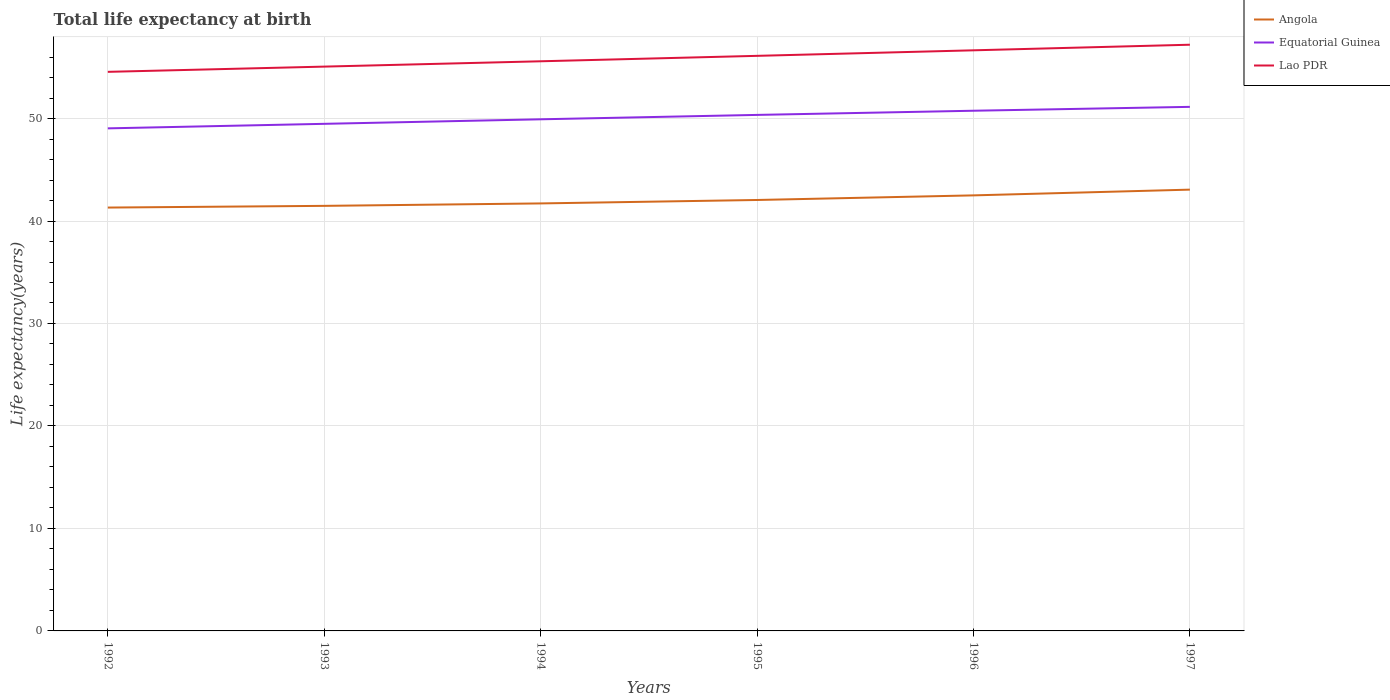How many different coloured lines are there?
Provide a succinct answer. 3. Does the line corresponding to Lao PDR intersect with the line corresponding to Angola?
Your response must be concise. No. Is the number of lines equal to the number of legend labels?
Make the answer very short. Yes. Across all years, what is the maximum life expectancy at birth in in Angola?
Your response must be concise. 41.31. What is the total life expectancy at birth in in Lao PDR in the graph?
Give a very brief answer. -0.55. What is the difference between the highest and the second highest life expectancy at birth in in Angola?
Keep it short and to the point. 1.75. How many lines are there?
Your answer should be compact. 3. What is the title of the graph?
Give a very brief answer. Total life expectancy at birth. Does "Tanzania" appear as one of the legend labels in the graph?
Offer a terse response. No. What is the label or title of the X-axis?
Make the answer very short. Years. What is the label or title of the Y-axis?
Provide a succinct answer. Life expectancy(years). What is the Life expectancy(years) in Angola in 1992?
Offer a very short reply. 41.31. What is the Life expectancy(years) of Equatorial Guinea in 1992?
Keep it short and to the point. 49.04. What is the Life expectancy(years) in Lao PDR in 1992?
Your response must be concise. 54.56. What is the Life expectancy(years) in Angola in 1993?
Your answer should be compact. 41.48. What is the Life expectancy(years) of Equatorial Guinea in 1993?
Your answer should be very brief. 49.48. What is the Life expectancy(years) in Lao PDR in 1993?
Offer a very short reply. 55.07. What is the Life expectancy(years) of Angola in 1994?
Your answer should be compact. 41.72. What is the Life expectancy(years) of Equatorial Guinea in 1994?
Keep it short and to the point. 49.93. What is the Life expectancy(years) in Lao PDR in 1994?
Make the answer very short. 55.59. What is the Life expectancy(years) of Angola in 1995?
Make the answer very short. 42.05. What is the Life expectancy(years) in Equatorial Guinea in 1995?
Keep it short and to the point. 50.35. What is the Life expectancy(years) in Lao PDR in 1995?
Give a very brief answer. 56.12. What is the Life expectancy(years) of Angola in 1996?
Make the answer very short. 42.5. What is the Life expectancy(years) of Equatorial Guinea in 1996?
Offer a very short reply. 50.76. What is the Life expectancy(years) in Lao PDR in 1996?
Your answer should be very brief. 56.66. What is the Life expectancy(years) of Angola in 1997?
Give a very brief answer. 43.06. What is the Life expectancy(years) of Equatorial Guinea in 1997?
Ensure brevity in your answer.  51.14. What is the Life expectancy(years) of Lao PDR in 1997?
Make the answer very short. 57.2. Across all years, what is the maximum Life expectancy(years) in Angola?
Offer a terse response. 43.06. Across all years, what is the maximum Life expectancy(years) of Equatorial Guinea?
Ensure brevity in your answer.  51.14. Across all years, what is the maximum Life expectancy(years) in Lao PDR?
Your answer should be compact. 57.2. Across all years, what is the minimum Life expectancy(years) in Angola?
Offer a very short reply. 41.31. Across all years, what is the minimum Life expectancy(years) in Equatorial Guinea?
Provide a short and direct response. 49.04. Across all years, what is the minimum Life expectancy(years) of Lao PDR?
Ensure brevity in your answer.  54.56. What is the total Life expectancy(years) in Angola in the graph?
Your answer should be very brief. 252.12. What is the total Life expectancy(years) of Equatorial Guinea in the graph?
Make the answer very short. 300.71. What is the total Life expectancy(years) in Lao PDR in the graph?
Make the answer very short. 335.19. What is the difference between the Life expectancy(years) in Angola in 1992 and that in 1993?
Keep it short and to the point. -0.17. What is the difference between the Life expectancy(years) of Equatorial Guinea in 1992 and that in 1993?
Your answer should be very brief. -0.44. What is the difference between the Life expectancy(years) of Lao PDR in 1992 and that in 1993?
Your answer should be compact. -0.51. What is the difference between the Life expectancy(years) in Angola in 1992 and that in 1994?
Keep it short and to the point. -0.4. What is the difference between the Life expectancy(years) in Equatorial Guinea in 1992 and that in 1994?
Your answer should be compact. -0.88. What is the difference between the Life expectancy(years) of Lao PDR in 1992 and that in 1994?
Your response must be concise. -1.03. What is the difference between the Life expectancy(years) in Angola in 1992 and that in 1995?
Keep it short and to the point. -0.74. What is the difference between the Life expectancy(years) of Equatorial Guinea in 1992 and that in 1995?
Give a very brief answer. -1.31. What is the difference between the Life expectancy(years) in Lao PDR in 1992 and that in 1995?
Give a very brief answer. -1.56. What is the difference between the Life expectancy(years) of Angola in 1992 and that in 1996?
Keep it short and to the point. -1.19. What is the difference between the Life expectancy(years) of Equatorial Guinea in 1992 and that in 1996?
Offer a very short reply. -1.72. What is the difference between the Life expectancy(years) in Lao PDR in 1992 and that in 1996?
Your answer should be very brief. -2.1. What is the difference between the Life expectancy(years) of Angola in 1992 and that in 1997?
Your answer should be compact. -1.75. What is the difference between the Life expectancy(years) in Equatorial Guinea in 1992 and that in 1997?
Your answer should be very brief. -2.1. What is the difference between the Life expectancy(years) in Lao PDR in 1992 and that in 1997?
Make the answer very short. -2.65. What is the difference between the Life expectancy(years) of Angola in 1993 and that in 1994?
Make the answer very short. -0.24. What is the difference between the Life expectancy(years) of Equatorial Guinea in 1993 and that in 1994?
Your response must be concise. -0.44. What is the difference between the Life expectancy(years) of Lao PDR in 1993 and that in 1994?
Keep it short and to the point. -0.52. What is the difference between the Life expectancy(years) in Angola in 1993 and that in 1995?
Make the answer very short. -0.57. What is the difference between the Life expectancy(years) in Equatorial Guinea in 1993 and that in 1995?
Provide a short and direct response. -0.87. What is the difference between the Life expectancy(years) in Lao PDR in 1993 and that in 1995?
Make the answer very short. -1.05. What is the difference between the Life expectancy(years) in Angola in 1993 and that in 1996?
Give a very brief answer. -1.02. What is the difference between the Life expectancy(years) of Equatorial Guinea in 1993 and that in 1996?
Provide a succinct answer. -1.28. What is the difference between the Life expectancy(years) of Lao PDR in 1993 and that in 1996?
Provide a succinct answer. -1.59. What is the difference between the Life expectancy(years) of Angola in 1993 and that in 1997?
Give a very brief answer. -1.58. What is the difference between the Life expectancy(years) of Equatorial Guinea in 1993 and that in 1997?
Offer a terse response. -1.66. What is the difference between the Life expectancy(years) of Lao PDR in 1993 and that in 1997?
Your answer should be compact. -2.14. What is the difference between the Life expectancy(years) of Angola in 1994 and that in 1995?
Your response must be concise. -0.34. What is the difference between the Life expectancy(years) of Equatorial Guinea in 1994 and that in 1995?
Make the answer very short. -0.43. What is the difference between the Life expectancy(years) in Lao PDR in 1994 and that in 1995?
Your answer should be very brief. -0.53. What is the difference between the Life expectancy(years) in Angola in 1994 and that in 1996?
Make the answer very short. -0.79. What is the difference between the Life expectancy(years) of Equatorial Guinea in 1994 and that in 1996?
Provide a succinct answer. -0.84. What is the difference between the Life expectancy(years) in Lao PDR in 1994 and that in 1996?
Your answer should be very brief. -1.07. What is the difference between the Life expectancy(years) of Angola in 1994 and that in 1997?
Ensure brevity in your answer.  -1.35. What is the difference between the Life expectancy(years) of Equatorial Guinea in 1994 and that in 1997?
Keep it short and to the point. -1.21. What is the difference between the Life expectancy(years) of Lao PDR in 1994 and that in 1997?
Make the answer very short. -1.62. What is the difference between the Life expectancy(years) in Angola in 1995 and that in 1996?
Offer a very short reply. -0.45. What is the difference between the Life expectancy(years) in Equatorial Guinea in 1995 and that in 1996?
Offer a very short reply. -0.41. What is the difference between the Life expectancy(years) of Lao PDR in 1995 and that in 1996?
Provide a succinct answer. -0.54. What is the difference between the Life expectancy(years) in Angola in 1995 and that in 1997?
Make the answer very short. -1.01. What is the difference between the Life expectancy(years) in Equatorial Guinea in 1995 and that in 1997?
Provide a short and direct response. -0.78. What is the difference between the Life expectancy(years) of Lao PDR in 1995 and that in 1997?
Provide a succinct answer. -1.09. What is the difference between the Life expectancy(years) of Angola in 1996 and that in 1997?
Keep it short and to the point. -0.56. What is the difference between the Life expectancy(years) of Equatorial Guinea in 1996 and that in 1997?
Your answer should be very brief. -0.38. What is the difference between the Life expectancy(years) of Lao PDR in 1996 and that in 1997?
Ensure brevity in your answer.  -0.55. What is the difference between the Life expectancy(years) in Angola in 1992 and the Life expectancy(years) in Equatorial Guinea in 1993?
Ensure brevity in your answer.  -8.17. What is the difference between the Life expectancy(years) in Angola in 1992 and the Life expectancy(years) in Lao PDR in 1993?
Make the answer very short. -13.75. What is the difference between the Life expectancy(years) in Equatorial Guinea in 1992 and the Life expectancy(years) in Lao PDR in 1993?
Make the answer very short. -6.03. What is the difference between the Life expectancy(years) of Angola in 1992 and the Life expectancy(years) of Equatorial Guinea in 1994?
Your response must be concise. -8.61. What is the difference between the Life expectancy(years) of Angola in 1992 and the Life expectancy(years) of Lao PDR in 1994?
Your response must be concise. -14.27. What is the difference between the Life expectancy(years) in Equatorial Guinea in 1992 and the Life expectancy(years) in Lao PDR in 1994?
Your answer should be very brief. -6.55. What is the difference between the Life expectancy(years) of Angola in 1992 and the Life expectancy(years) of Equatorial Guinea in 1995?
Offer a terse response. -9.04. What is the difference between the Life expectancy(years) in Angola in 1992 and the Life expectancy(years) in Lao PDR in 1995?
Offer a very short reply. -14.8. What is the difference between the Life expectancy(years) of Equatorial Guinea in 1992 and the Life expectancy(years) of Lao PDR in 1995?
Your answer should be compact. -7.08. What is the difference between the Life expectancy(years) of Angola in 1992 and the Life expectancy(years) of Equatorial Guinea in 1996?
Make the answer very short. -9.45. What is the difference between the Life expectancy(years) in Angola in 1992 and the Life expectancy(years) in Lao PDR in 1996?
Your answer should be very brief. -15.34. What is the difference between the Life expectancy(years) in Equatorial Guinea in 1992 and the Life expectancy(years) in Lao PDR in 1996?
Keep it short and to the point. -7.62. What is the difference between the Life expectancy(years) in Angola in 1992 and the Life expectancy(years) in Equatorial Guinea in 1997?
Your answer should be compact. -9.83. What is the difference between the Life expectancy(years) of Angola in 1992 and the Life expectancy(years) of Lao PDR in 1997?
Make the answer very short. -15.89. What is the difference between the Life expectancy(years) in Equatorial Guinea in 1992 and the Life expectancy(years) in Lao PDR in 1997?
Provide a short and direct response. -8.16. What is the difference between the Life expectancy(years) of Angola in 1993 and the Life expectancy(years) of Equatorial Guinea in 1994?
Offer a very short reply. -8.45. What is the difference between the Life expectancy(years) of Angola in 1993 and the Life expectancy(years) of Lao PDR in 1994?
Offer a very short reply. -14.11. What is the difference between the Life expectancy(years) in Equatorial Guinea in 1993 and the Life expectancy(years) in Lao PDR in 1994?
Give a very brief answer. -6.1. What is the difference between the Life expectancy(years) of Angola in 1993 and the Life expectancy(years) of Equatorial Guinea in 1995?
Keep it short and to the point. -8.88. What is the difference between the Life expectancy(years) in Angola in 1993 and the Life expectancy(years) in Lao PDR in 1995?
Make the answer very short. -14.64. What is the difference between the Life expectancy(years) in Equatorial Guinea in 1993 and the Life expectancy(years) in Lao PDR in 1995?
Give a very brief answer. -6.63. What is the difference between the Life expectancy(years) in Angola in 1993 and the Life expectancy(years) in Equatorial Guinea in 1996?
Offer a very short reply. -9.28. What is the difference between the Life expectancy(years) in Angola in 1993 and the Life expectancy(years) in Lao PDR in 1996?
Give a very brief answer. -15.18. What is the difference between the Life expectancy(years) in Equatorial Guinea in 1993 and the Life expectancy(years) in Lao PDR in 1996?
Keep it short and to the point. -7.17. What is the difference between the Life expectancy(years) in Angola in 1993 and the Life expectancy(years) in Equatorial Guinea in 1997?
Offer a terse response. -9.66. What is the difference between the Life expectancy(years) in Angola in 1993 and the Life expectancy(years) in Lao PDR in 1997?
Ensure brevity in your answer.  -15.73. What is the difference between the Life expectancy(years) in Equatorial Guinea in 1993 and the Life expectancy(years) in Lao PDR in 1997?
Keep it short and to the point. -7.72. What is the difference between the Life expectancy(years) in Angola in 1994 and the Life expectancy(years) in Equatorial Guinea in 1995?
Offer a very short reply. -8.64. What is the difference between the Life expectancy(years) of Angola in 1994 and the Life expectancy(years) of Lao PDR in 1995?
Provide a succinct answer. -14.4. What is the difference between the Life expectancy(years) in Equatorial Guinea in 1994 and the Life expectancy(years) in Lao PDR in 1995?
Your answer should be very brief. -6.19. What is the difference between the Life expectancy(years) in Angola in 1994 and the Life expectancy(years) in Equatorial Guinea in 1996?
Your answer should be very brief. -9.05. What is the difference between the Life expectancy(years) of Angola in 1994 and the Life expectancy(years) of Lao PDR in 1996?
Provide a succinct answer. -14.94. What is the difference between the Life expectancy(years) in Equatorial Guinea in 1994 and the Life expectancy(years) in Lao PDR in 1996?
Ensure brevity in your answer.  -6.73. What is the difference between the Life expectancy(years) of Angola in 1994 and the Life expectancy(years) of Equatorial Guinea in 1997?
Provide a short and direct response. -9.42. What is the difference between the Life expectancy(years) of Angola in 1994 and the Life expectancy(years) of Lao PDR in 1997?
Keep it short and to the point. -15.49. What is the difference between the Life expectancy(years) of Equatorial Guinea in 1994 and the Life expectancy(years) of Lao PDR in 1997?
Your answer should be compact. -7.28. What is the difference between the Life expectancy(years) of Angola in 1995 and the Life expectancy(years) of Equatorial Guinea in 1996?
Offer a very short reply. -8.71. What is the difference between the Life expectancy(years) in Angola in 1995 and the Life expectancy(years) in Lao PDR in 1996?
Provide a succinct answer. -14.61. What is the difference between the Life expectancy(years) of Equatorial Guinea in 1995 and the Life expectancy(years) of Lao PDR in 1996?
Your response must be concise. -6.3. What is the difference between the Life expectancy(years) in Angola in 1995 and the Life expectancy(years) in Equatorial Guinea in 1997?
Offer a very short reply. -9.09. What is the difference between the Life expectancy(years) of Angola in 1995 and the Life expectancy(years) of Lao PDR in 1997?
Make the answer very short. -15.15. What is the difference between the Life expectancy(years) in Equatorial Guinea in 1995 and the Life expectancy(years) in Lao PDR in 1997?
Offer a very short reply. -6.85. What is the difference between the Life expectancy(years) in Angola in 1996 and the Life expectancy(years) in Equatorial Guinea in 1997?
Ensure brevity in your answer.  -8.64. What is the difference between the Life expectancy(years) of Angola in 1996 and the Life expectancy(years) of Lao PDR in 1997?
Offer a very short reply. -14.7. What is the difference between the Life expectancy(years) in Equatorial Guinea in 1996 and the Life expectancy(years) in Lao PDR in 1997?
Keep it short and to the point. -6.44. What is the average Life expectancy(years) of Angola per year?
Ensure brevity in your answer.  42.02. What is the average Life expectancy(years) in Equatorial Guinea per year?
Keep it short and to the point. 50.12. What is the average Life expectancy(years) of Lao PDR per year?
Offer a terse response. 55.86. In the year 1992, what is the difference between the Life expectancy(years) of Angola and Life expectancy(years) of Equatorial Guinea?
Your answer should be very brief. -7.73. In the year 1992, what is the difference between the Life expectancy(years) of Angola and Life expectancy(years) of Lao PDR?
Your answer should be very brief. -13.24. In the year 1992, what is the difference between the Life expectancy(years) in Equatorial Guinea and Life expectancy(years) in Lao PDR?
Provide a short and direct response. -5.51. In the year 1993, what is the difference between the Life expectancy(years) in Angola and Life expectancy(years) in Equatorial Guinea?
Your answer should be very brief. -8.01. In the year 1993, what is the difference between the Life expectancy(years) in Angola and Life expectancy(years) in Lao PDR?
Provide a short and direct response. -13.59. In the year 1993, what is the difference between the Life expectancy(years) in Equatorial Guinea and Life expectancy(years) in Lao PDR?
Offer a terse response. -5.58. In the year 1994, what is the difference between the Life expectancy(years) of Angola and Life expectancy(years) of Equatorial Guinea?
Make the answer very short. -8.21. In the year 1994, what is the difference between the Life expectancy(years) in Angola and Life expectancy(years) in Lao PDR?
Offer a very short reply. -13.87. In the year 1994, what is the difference between the Life expectancy(years) of Equatorial Guinea and Life expectancy(years) of Lao PDR?
Offer a very short reply. -5.66. In the year 1995, what is the difference between the Life expectancy(years) of Angola and Life expectancy(years) of Equatorial Guinea?
Your response must be concise. -8.3. In the year 1995, what is the difference between the Life expectancy(years) of Angola and Life expectancy(years) of Lao PDR?
Your answer should be compact. -14.07. In the year 1995, what is the difference between the Life expectancy(years) in Equatorial Guinea and Life expectancy(years) in Lao PDR?
Make the answer very short. -5.76. In the year 1996, what is the difference between the Life expectancy(years) of Angola and Life expectancy(years) of Equatorial Guinea?
Provide a short and direct response. -8.26. In the year 1996, what is the difference between the Life expectancy(years) in Angola and Life expectancy(years) in Lao PDR?
Offer a very short reply. -14.16. In the year 1996, what is the difference between the Life expectancy(years) in Equatorial Guinea and Life expectancy(years) in Lao PDR?
Keep it short and to the point. -5.9. In the year 1997, what is the difference between the Life expectancy(years) in Angola and Life expectancy(years) in Equatorial Guinea?
Provide a short and direct response. -8.08. In the year 1997, what is the difference between the Life expectancy(years) of Angola and Life expectancy(years) of Lao PDR?
Provide a short and direct response. -14.14. In the year 1997, what is the difference between the Life expectancy(years) of Equatorial Guinea and Life expectancy(years) of Lao PDR?
Give a very brief answer. -6.06. What is the ratio of the Life expectancy(years) of Angola in 1992 to that in 1993?
Provide a succinct answer. 1. What is the ratio of the Life expectancy(years) of Lao PDR in 1992 to that in 1993?
Provide a short and direct response. 0.99. What is the ratio of the Life expectancy(years) in Angola in 1992 to that in 1994?
Give a very brief answer. 0.99. What is the ratio of the Life expectancy(years) of Equatorial Guinea in 1992 to that in 1994?
Provide a short and direct response. 0.98. What is the ratio of the Life expectancy(years) of Lao PDR in 1992 to that in 1994?
Provide a succinct answer. 0.98. What is the ratio of the Life expectancy(years) in Angola in 1992 to that in 1995?
Make the answer very short. 0.98. What is the ratio of the Life expectancy(years) in Equatorial Guinea in 1992 to that in 1995?
Provide a short and direct response. 0.97. What is the ratio of the Life expectancy(years) of Lao PDR in 1992 to that in 1995?
Provide a succinct answer. 0.97. What is the ratio of the Life expectancy(years) in Angola in 1992 to that in 1996?
Ensure brevity in your answer.  0.97. What is the ratio of the Life expectancy(years) in Equatorial Guinea in 1992 to that in 1996?
Your response must be concise. 0.97. What is the ratio of the Life expectancy(years) of Lao PDR in 1992 to that in 1996?
Your answer should be very brief. 0.96. What is the ratio of the Life expectancy(years) in Angola in 1992 to that in 1997?
Your answer should be very brief. 0.96. What is the ratio of the Life expectancy(years) of Lao PDR in 1992 to that in 1997?
Your response must be concise. 0.95. What is the ratio of the Life expectancy(years) of Equatorial Guinea in 1993 to that in 1994?
Your answer should be compact. 0.99. What is the ratio of the Life expectancy(years) in Lao PDR in 1993 to that in 1994?
Make the answer very short. 0.99. What is the ratio of the Life expectancy(years) in Angola in 1993 to that in 1995?
Keep it short and to the point. 0.99. What is the ratio of the Life expectancy(years) of Equatorial Guinea in 1993 to that in 1995?
Make the answer very short. 0.98. What is the ratio of the Life expectancy(years) in Lao PDR in 1993 to that in 1995?
Your answer should be compact. 0.98. What is the ratio of the Life expectancy(years) in Angola in 1993 to that in 1996?
Offer a terse response. 0.98. What is the ratio of the Life expectancy(years) of Equatorial Guinea in 1993 to that in 1996?
Give a very brief answer. 0.97. What is the ratio of the Life expectancy(years) of Lao PDR in 1993 to that in 1996?
Provide a succinct answer. 0.97. What is the ratio of the Life expectancy(years) of Angola in 1993 to that in 1997?
Your answer should be compact. 0.96. What is the ratio of the Life expectancy(years) of Equatorial Guinea in 1993 to that in 1997?
Give a very brief answer. 0.97. What is the ratio of the Life expectancy(years) of Lao PDR in 1993 to that in 1997?
Offer a very short reply. 0.96. What is the ratio of the Life expectancy(years) in Angola in 1994 to that in 1995?
Your answer should be very brief. 0.99. What is the ratio of the Life expectancy(years) in Lao PDR in 1994 to that in 1995?
Offer a terse response. 0.99. What is the ratio of the Life expectancy(years) in Angola in 1994 to that in 1996?
Offer a very short reply. 0.98. What is the ratio of the Life expectancy(years) of Equatorial Guinea in 1994 to that in 1996?
Offer a very short reply. 0.98. What is the ratio of the Life expectancy(years) in Lao PDR in 1994 to that in 1996?
Provide a short and direct response. 0.98. What is the ratio of the Life expectancy(years) of Angola in 1994 to that in 1997?
Provide a succinct answer. 0.97. What is the ratio of the Life expectancy(years) of Equatorial Guinea in 1994 to that in 1997?
Your answer should be very brief. 0.98. What is the ratio of the Life expectancy(years) of Lao PDR in 1994 to that in 1997?
Give a very brief answer. 0.97. What is the ratio of the Life expectancy(years) in Angola in 1995 to that in 1996?
Your answer should be compact. 0.99. What is the ratio of the Life expectancy(years) of Angola in 1995 to that in 1997?
Provide a short and direct response. 0.98. What is the ratio of the Life expectancy(years) of Equatorial Guinea in 1995 to that in 1997?
Your response must be concise. 0.98. What is the ratio of the Life expectancy(years) of Lao PDR in 1995 to that in 1997?
Provide a short and direct response. 0.98. What is the ratio of the Life expectancy(years) in Equatorial Guinea in 1996 to that in 1997?
Ensure brevity in your answer.  0.99. What is the ratio of the Life expectancy(years) of Lao PDR in 1996 to that in 1997?
Offer a terse response. 0.99. What is the difference between the highest and the second highest Life expectancy(years) of Angola?
Offer a terse response. 0.56. What is the difference between the highest and the second highest Life expectancy(years) in Equatorial Guinea?
Keep it short and to the point. 0.38. What is the difference between the highest and the second highest Life expectancy(years) of Lao PDR?
Keep it short and to the point. 0.55. What is the difference between the highest and the lowest Life expectancy(years) of Angola?
Provide a short and direct response. 1.75. What is the difference between the highest and the lowest Life expectancy(years) in Equatorial Guinea?
Your response must be concise. 2.1. What is the difference between the highest and the lowest Life expectancy(years) in Lao PDR?
Provide a short and direct response. 2.65. 